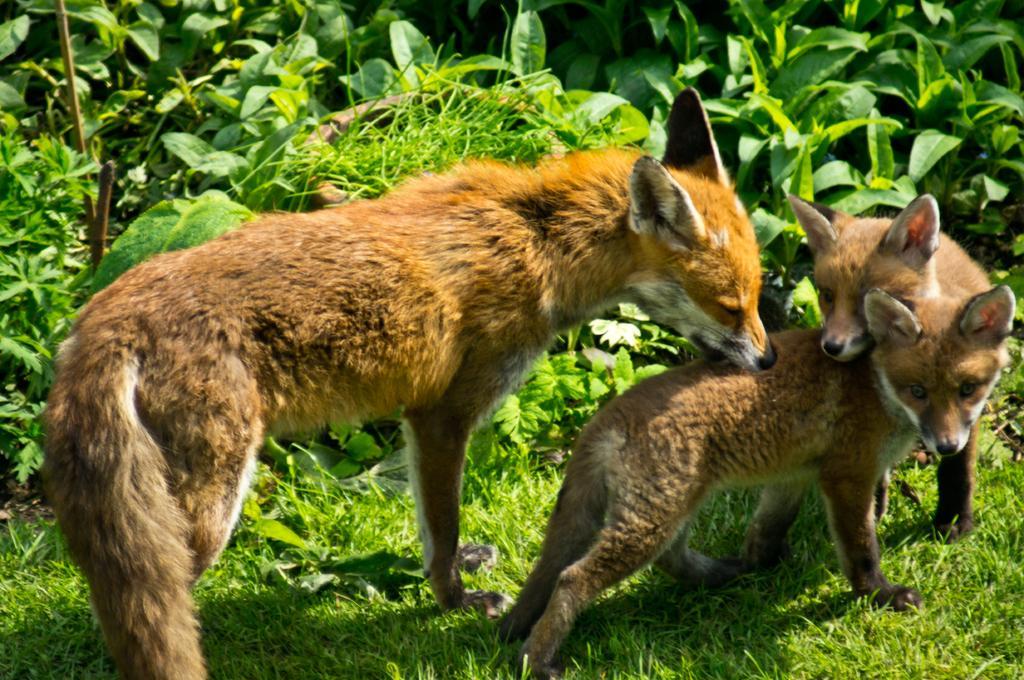How would you summarize this image in a sentence or two? In this picture I can see few foxes and I can see trees and grass on the ground. 